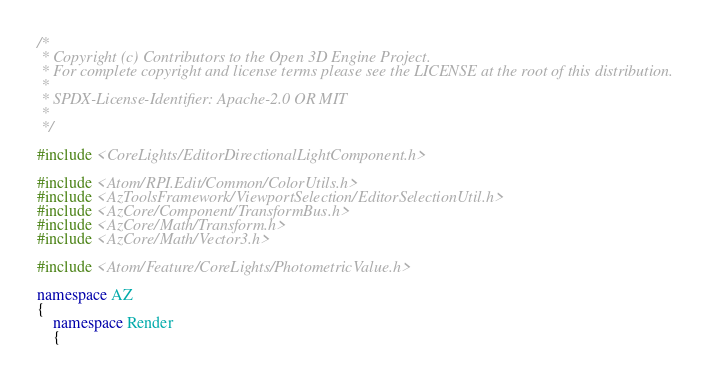Convert code to text. <code><loc_0><loc_0><loc_500><loc_500><_C++_>/*
 * Copyright (c) Contributors to the Open 3D Engine Project.
 * For complete copyright and license terms please see the LICENSE at the root of this distribution.
 *
 * SPDX-License-Identifier: Apache-2.0 OR MIT
 *
 */

#include <CoreLights/EditorDirectionalLightComponent.h>

#include <Atom/RPI.Edit/Common/ColorUtils.h>
#include <AzToolsFramework/ViewportSelection/EditorSelectionUtil.h>
#include <AzCore/Component/TransformBus.h>
#include <AzCore/Math/Transform.h>
#include <AzCore/Math/Vector3.h>

#include <Atom/Feature/CoreLights/PhotometricValue.h>

namespace AZ
{
    namespace Render
    {</code> 